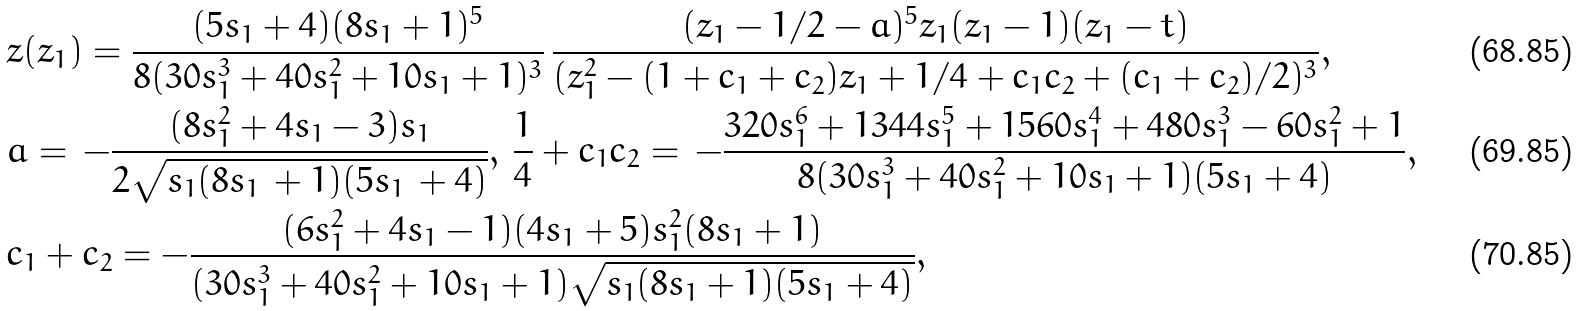<formula> <loc_0><loc_0><loc_500><loc_500>& z ( z _ { 1 } ) = \frac { ( 5 s _ { 1 } + 4 ) ( 8 s _ { 1 } + 1 ) ^ { 5 } } { 8 ( 3 0 s _ { 1 } ^ { 3 } + 4 0 s _ { 1 } ^ { 2 } + 1 0 s _ { 1 } + 1 ) ^ { 3 } } \, \frac { ( z _ { 1 } - 1 / 2 - a ) ^ { 5 } z _ { 1 } ( z _ { 1 } - 1 ) ( z _ { 1 } - t ) } { ( z _ { 1 } ^ { 2 } - ( 1 + c _ { 1 } + c _ { 2 } ) z _ { 1 } + 1 / 4 + c _ { 1 } c _ { 2 } + ( c _ { 1 } + c _ { 2 } ) / 2 ) ^ { 3 } } , \\ & a = \, - \frac { ( 8 s _ { 1 } ^ { 2 } + 4 s _ { 1 } - 3 ) s _ { 1 } } { 2 \sqrt { s _ { 1 } ( 8 s _ { 1 } \, + 1 ) ( 5 s _ { 1 } \, + 4 ) } } , \, \frac { 1 } { 4 } + c _ { 1 } c _ { 2 } = \, - \frac { 3 2 0 s _ { 1 } ^ { 6 } + 1 3 4 4 s _ { 1 } ^ { 5 } + 1 5 6 0 s _ { 1 } ^ { 4 } + 4 8 0 s _ { 1 } ^ { 3 } - 6 0 s _ { 1 } ^ { 2 } + 1 } { 8 ( 3 0 s _ { 1 } ^ { 3 } + 4 0 s _ { 1 } ^ { 2 } + 1 0 s _ { 1 } + 1 ) ( 5 s _ { 1 } + 4 ) } , \\ & c _ { 1 } + c _ { 2 } = - \frac { ( 6 s _ { 1 } ^ { 2 } + 4 s _ { 1 } - 1 ) ( 4 s _ { 1 } + 5 ) s _ { 1 } ^ { 2 } ( 8 s _ { 1 } + 1 ) } { ( 3 0 s _ { 1 } ^ { 3 } + 4 0 s _ { 1 } ^ { 2 } + 1 0 s _ { 1 } + 1 ) \sqrt { s _ { 1 } ( 8 s _ { 1 } + 1 ) ( 5 s _ { 1 } + 4 ) } } ,</formula> 